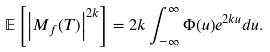Convert formula to latex. <formula><loc_0><loc_0><loc_500><loc_500>\mathbb { E } \left [ \left | M _ { f } ( T ) \right | ^ { 2 k } \right ] = 2 k \int _ { - \infty } ^ { \infty } \Phi ( u ) e ^ { 2 k u } d u .</formula> 